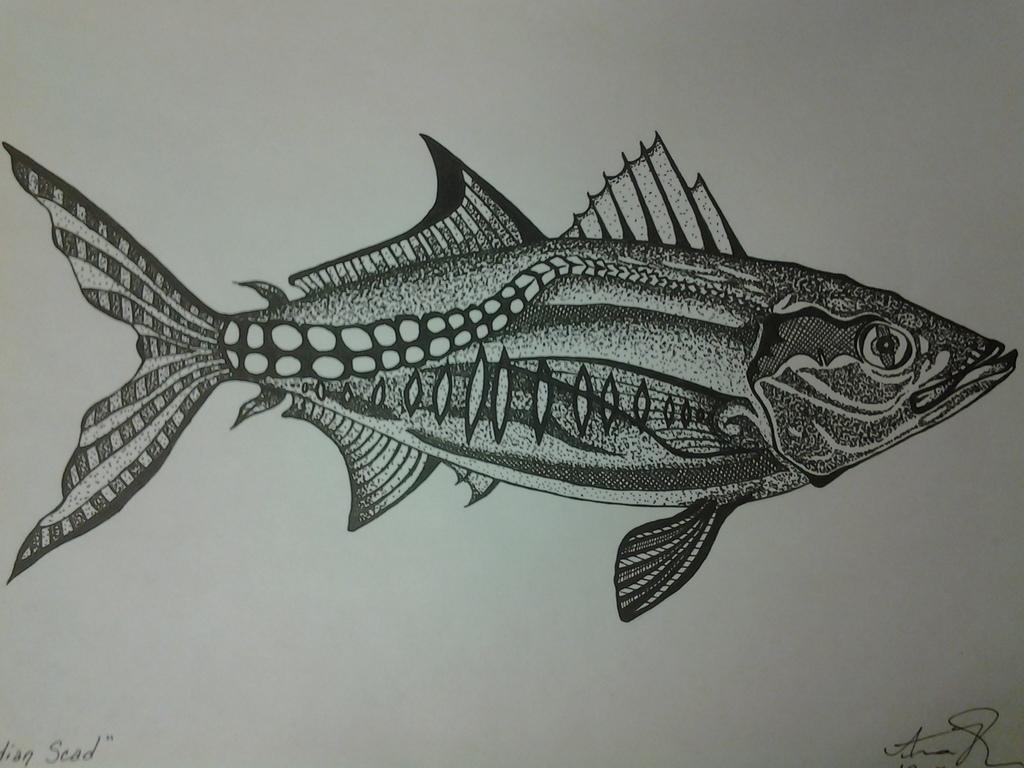Please provide a concise description of this image. This is a pencil drawing of a fish made on white paper. 